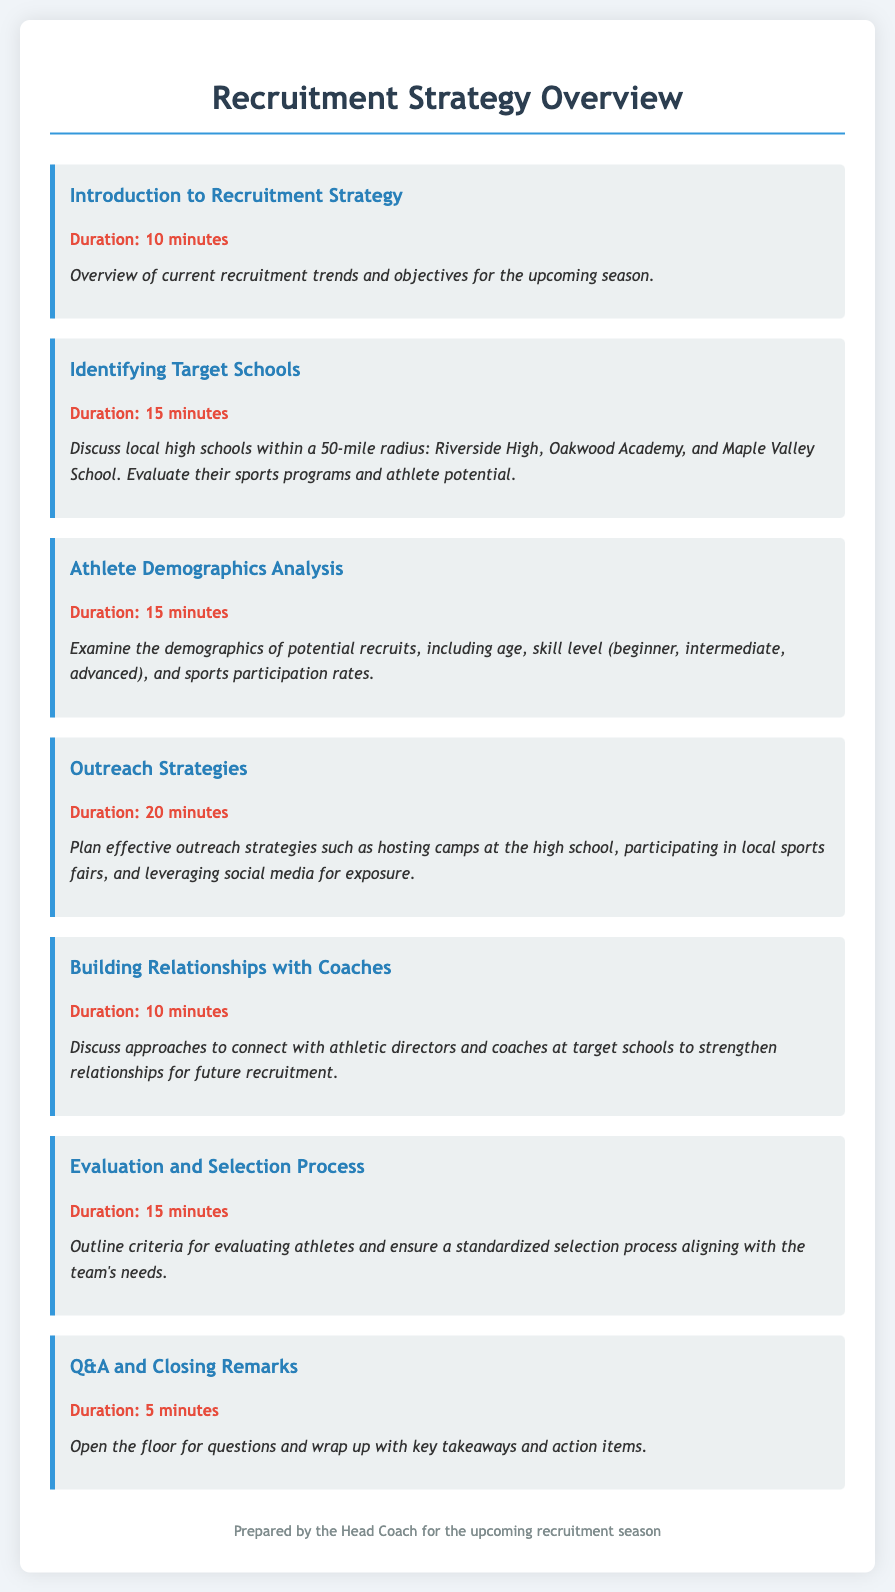what is the total duration of the agenda? The total duration is the sum of all durations mentioned in the agenda items, which is 10 + 15 + 15 + 20 + 10 + 15 + 5 = 90 minutes.
Answer: 90 minutes which schools are identified as target schools? The target schools mentioned in the document are Riverside High, Oakwood Academy, and Maple Valley School.
Answer: Riverside High, Oakwood Academy, Maple Valley School what is the focus of the athlete demographics analysis? The focus is on examining demographics including age, skill level, and sports participation rates.
Answer: Age, skill level, sports participation rates how many minutes are allocated to outreach strategies? The document specifies that outreach strategies are allocated 20 minutes in the agenda.
Answer: 20 minutes what is the main objective of the introduction to the recruitment strategy? The main objective is to provide an overview of current recruitment trends and objectives for the upcoming season.
Answer: Overview of current recruitment trends and objectives which item discusses the evaluation criteria for athletes? The evaluation and selection process agenda item outlines the criteria for evaluating athletes.
Answer: Evaluation and selection process how long is the Q&A and closing remarks session? The session is allocated 5 minutes in the agenda.
Answer: 5 minutes what is a recommended outreach strategy mentioned in the agenda? Hosting camps at the high school is one of the recommended outreach strategies.
Answer: Hosting camps at the high school 